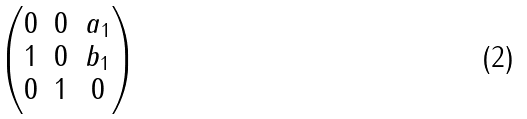Convert formula to latex. <formula><loc_0><loc_0><loc_500><loc_500>\begin{pmatrix} 0 & 0 & a _ { 1 } \\ 1 & 0 & b _ { 1 } \\ 0 & 1 & 0 \end{pmatrix}</formula> 